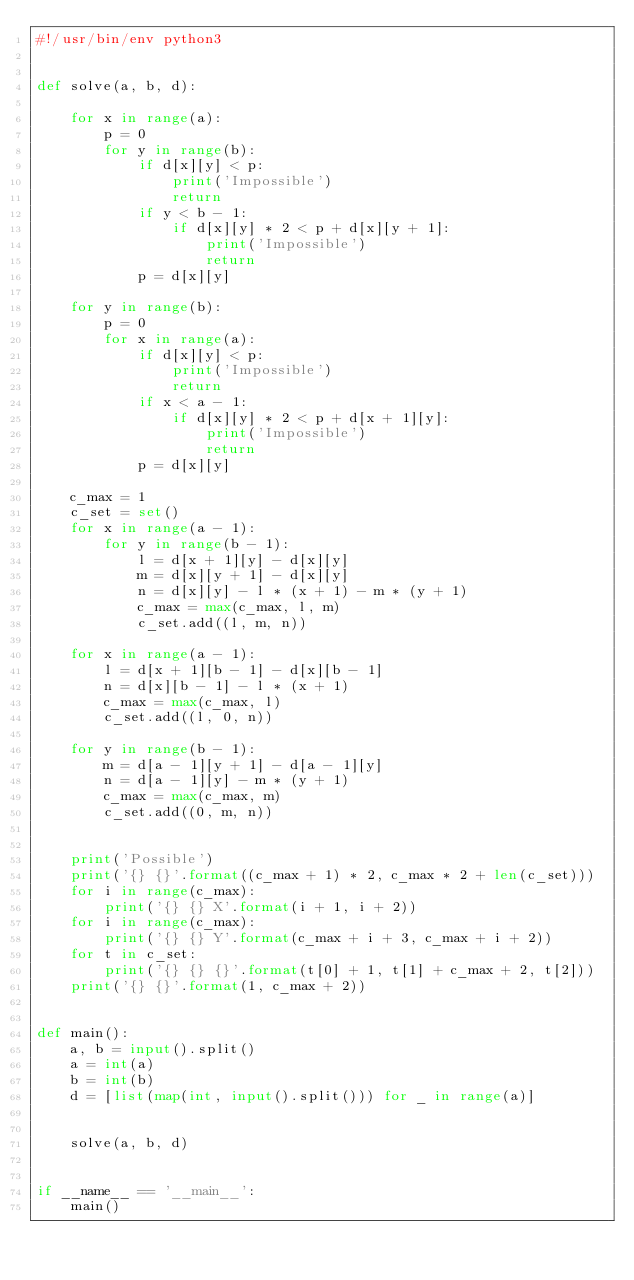Convert code to text. <code><loc_0><loc_0><loc_500><loc_500><_Python_>#!/usr/bin/env python3


def solve(a, b, d):

    for x in range(a):
        p = 0
        for y in range(b):
            if d[x][y] < p:
                print('Impossible')
                return
            if y < b - 1:
                if d[x][y] * 2 < p + d[x][y + 1]:
                    print('Impossible')
                    return
            p = d[x][y]

    for y in range(b):
        p = 0
        for x in range(a):
            if d[x][y] < p:
                print('Impossible')
                return
            if x < a - 1:
                if d[x][y] * 2 < p + d[x + 1][y]:
                    print('Impossible')
                    return
            p = d[x][y]

    c_max = 1
    c_set = set()
    for x in range(a - 1):
        for y in range(b - 1):
            l = d[x + 1][y] - d[x][y]
            m = d[x][y + 1] - d[x][y]
            n = d[x][y] - l * (x + 1) - m * (y + 1)
            c_max = max(c_max, l, m)
            c_set.add((l, m, n))

    for x in range(a - 1):
        l = d[x + 1][b - 1] - d[x][b - 1]
        n = d[x][b - 1] - l * (x + 1)
        c_max = max(c_max, l)
        c_set.add((l, 0, n))

    for y in range(b - 1):
        m = d[a - 1][y + 1] - d[a - 1][y]
        n = d[a - 1][y] - m * (y + 1)
        c_max = max(c_max, m)
        c_set.add((0, m, n))


    print('Possible')
    print('{} {}'.format((c_max + 1) * 2, c_max * 2 + len(c_set)))
    for i in range(c_max):
        print('{} {} X'.format(i + 1, i + 2))
    for i in range(c_max):
        print('{} {} Y'.format(c_max + i + 3, c_max + i + 2))
    for t in c_set:
        print('{} {} {}'.format(t[0] + 1, t[1] + c_max + 2, t[2]))
    print('{} {}'.format(1, c_max + 2))


def main():
    a, b = input().split()
    a = int(a)
    b = int(b)
    d = [list(map(int, input().split())) for _ in range(a)]


    solve(a, b, d)


if __name__ == '__main__':
    main()

</code> 